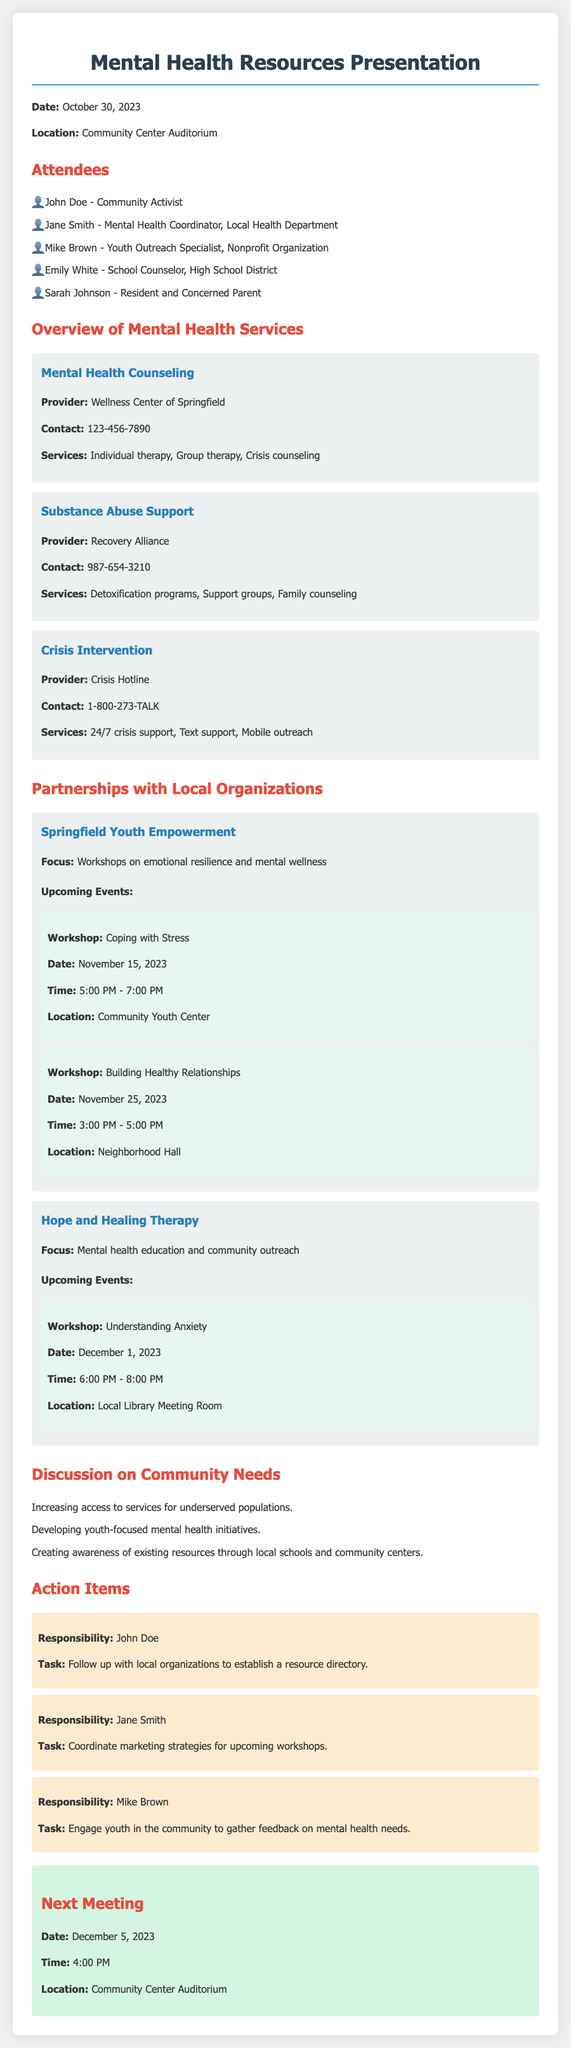What date was the meeting held? The date of the meeting is clearly stated in the document as October 30, 2023.
Answer: October 30, 2023 Who is the Mental Health Coordinator from the Local Health Department? The document lists Jane Smith as the Mental Health Coordinator representing the Local Health Department.
Answer: Jane Smith What are the services provided by the Wellness Center of Springfield? The document specifies that the Wellness Center of Springfield offers individual therapy, group therapy, and crisis counseling.
Answer: Individual therapy, Group therapy, Crisis counseling What is the contact number for the Crisis Hotline? The contact number for the Crisis Hotline is provided in the overview section of the document as 1-800-273-TALK.
Answer: 1-800-273-TALK Which organization focuses on workshops about emotional resilience? The document lists Springfield Youth Empowerment as the organization focusing on workshops related to emotional resilience and mental wellness.
Answer: Springfield Youth Empowerment What upcoming workshop is scheduled for November 25, 2023? The document outlines that the workshop titled "Building Healthy Relationships" is scheduled for November 25, 2023.
Answer: Building Healthy Relationships How many action items were discussed in the meeting? The document details three specific action items that were discussed during the meeting.
Answer: 3 What is the date and time of the next meeting? The next meeting is scheduled for December 5, 2023, at 4:00 PM according to the document.
Answer: December 5, 2023, 4:00 PM 